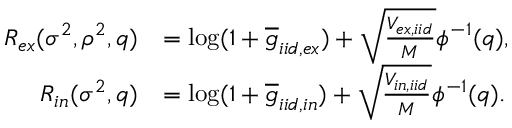<formula> <loc_0><loc_0><loc_500><loc_500>\begin{array} { r l } { R _ { e x } ( \sigma ^ { 2 } , \rho ^ { 2 } , q ) } & { = \log ( 1 + \overline { g } _ { i i d , e x } ) + \sqrt { \frac { V _ { e x , i i d } } { M } } \phi ^ { - 1 } ( q ) , } \\ { R _ { i n } ( \sigma ^ { 2 } , q ) } & { = \log ( 1 + \overline { g } _ { i i d , i n } ) + \sqrt { \frac { V _ { i n , i i d } } { M } } \phi ^ { - 1 } ( q ) . } \end{array}</formula> 